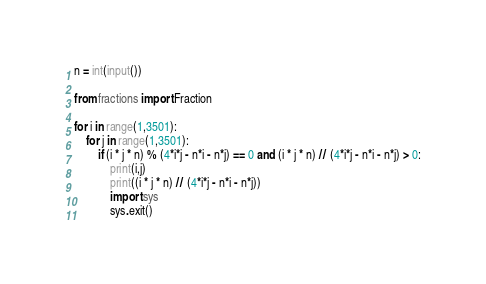<code> <loc_0><loc_0><loc_500><loc_500><_Python_>n = int(input())

from fractions import Fraction

for i in range(1,3501):
    for j in range(1,3501):
        if (i * j * n) % (4*i*j - n*i - n*j) == 0 and (i * j * n) // (4*i*j - n*i - n*j) > 0:
            print(i,j)
            print((i * j * n) // (4*i*j - n*i - n*j))
            import sys
            sys.exit()</code> 